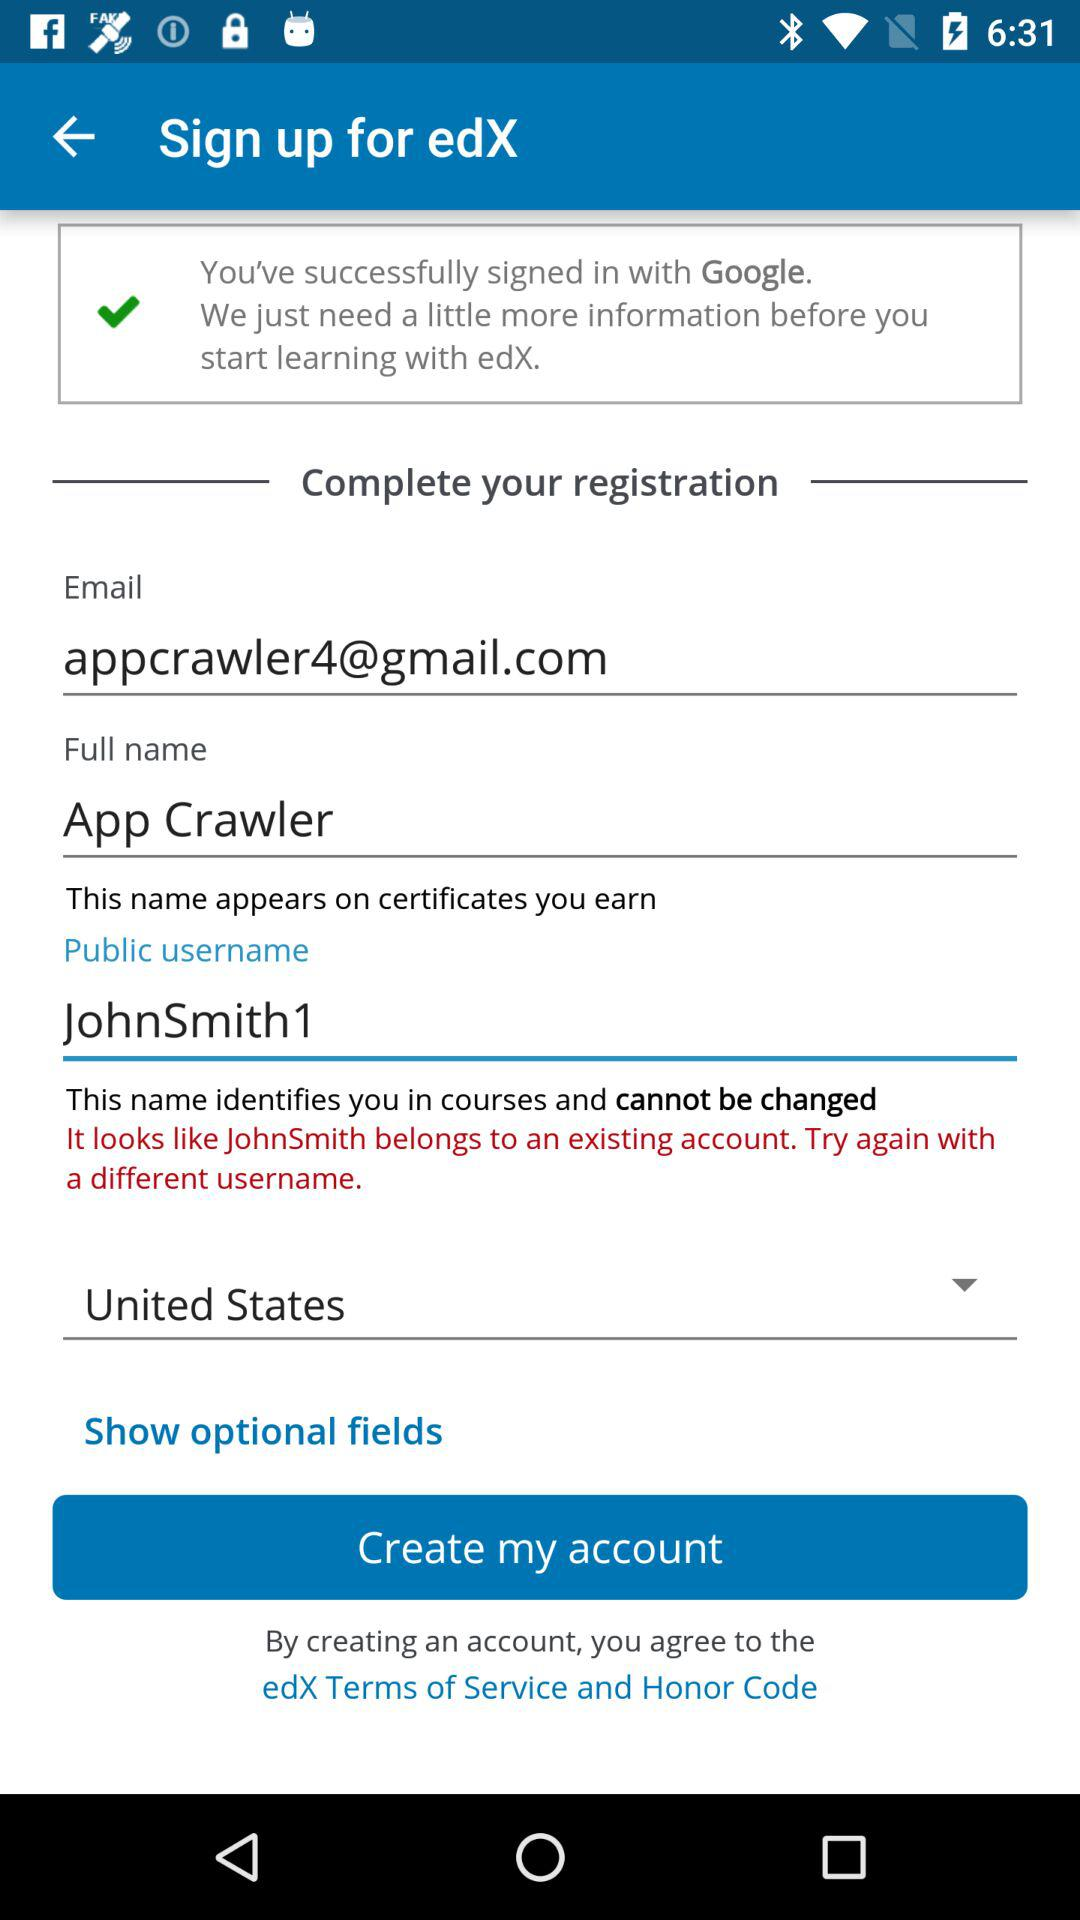Which option is selected? The selected option is "United States". 